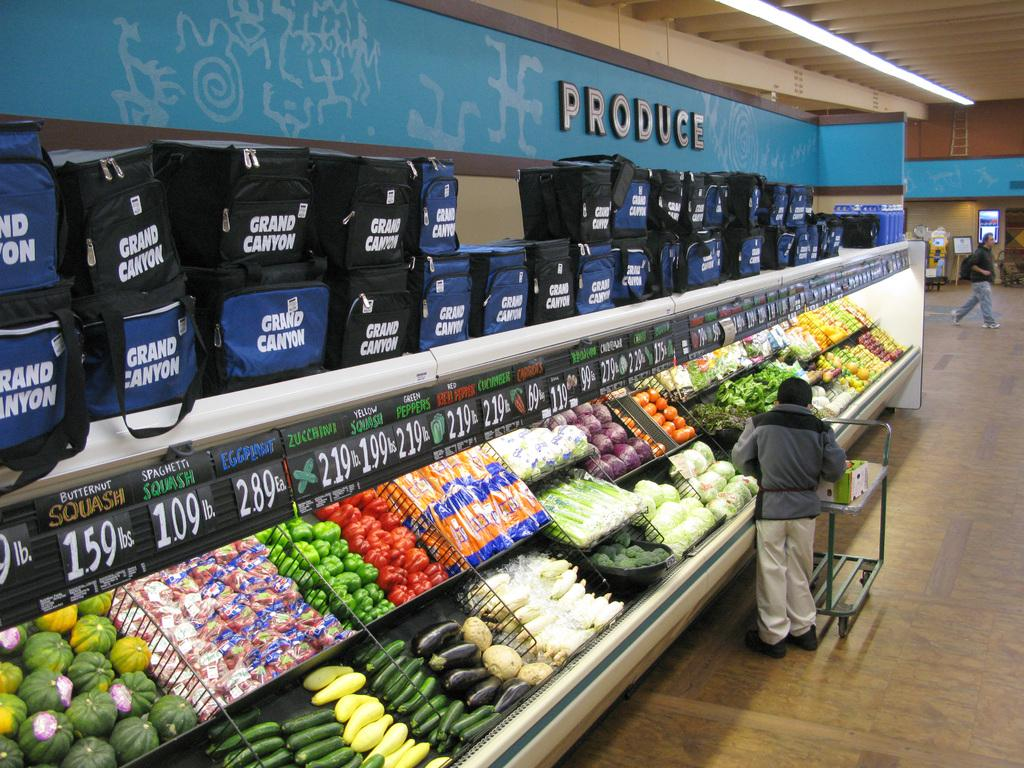<image>
Write a terse but informative summary of the picture. A produce section at a grocery store with a sign that says produce. 